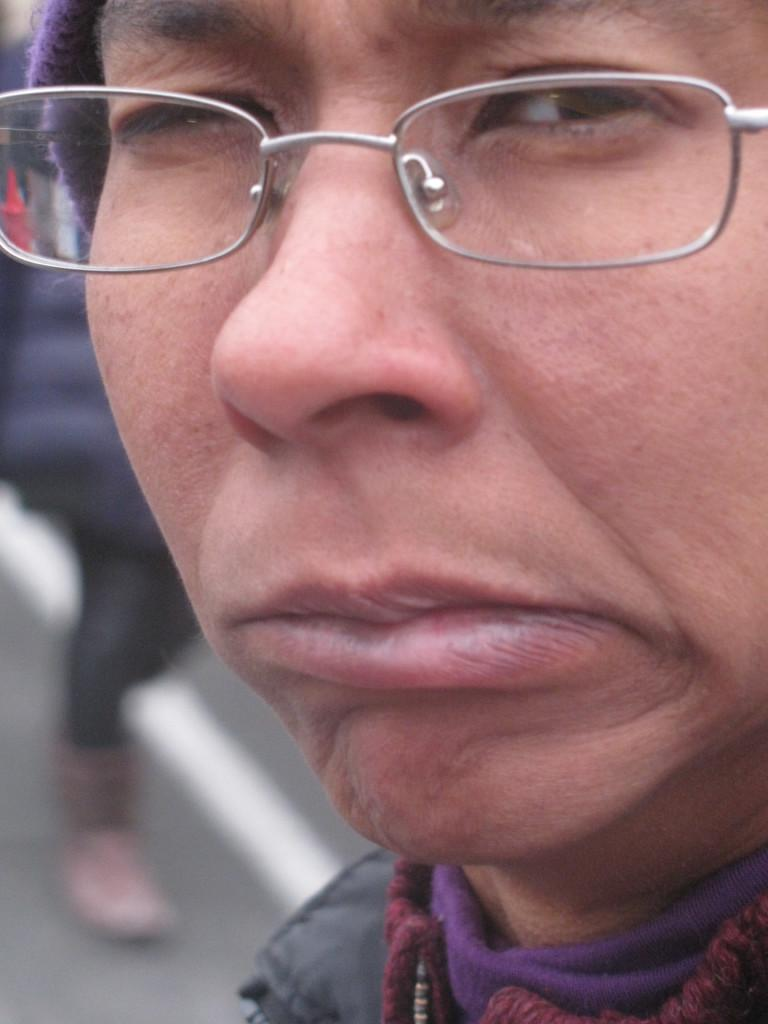Who is present in the image? There is a person in the image. Can you describe the scene in the background? There is another person in the background of the image, and they are walking on a road. What type of appliance can be seen in the image? There is no appliance present in the image. How many calculators are visible in the image? There are no calculators visible in the image. 